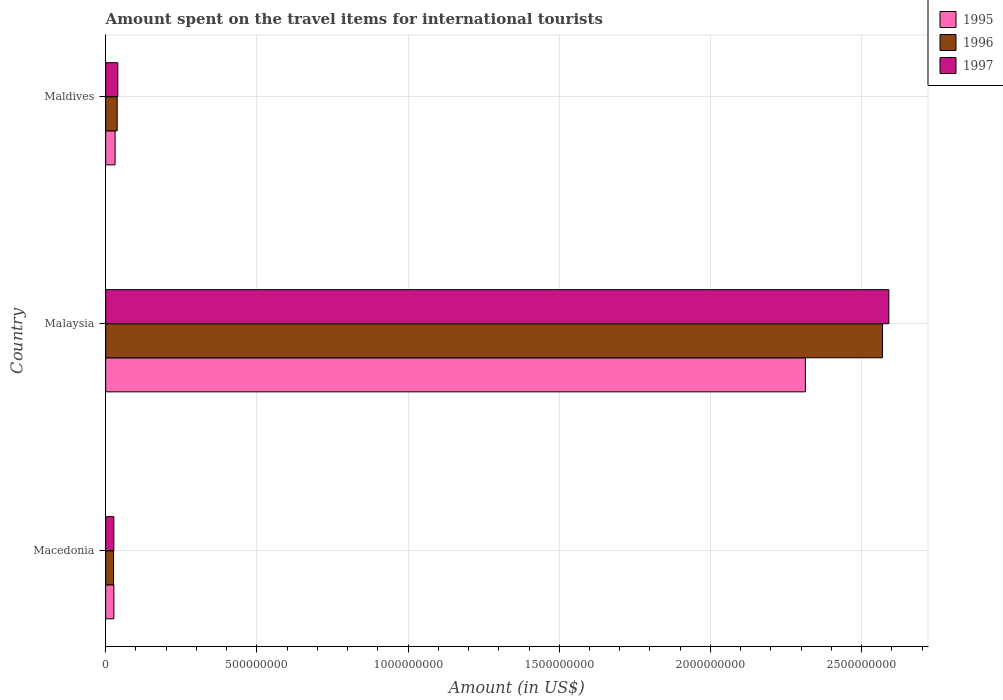Are the number of bars per tick equal to the number of legend labels?
Make the answer very short. Yes. How many bars are there on the 3rd tick from the bottom?
Offer a terse response. 3. What is the label of the 1st group of bars from the top?
Offer a terse response. Maldives. In how many cases, is the number of bars for a given country not equal to the number of legend labels?
Make the answer very short. 0. What is the amount spent on the travel items for international tourists in 1995 in Malaysia?
Offer a very short reply. 2.31e+09. Across all countries, what is the maximum amount spent on the travel items for international tourists in 1995?
Give a very brief answer. 2.31e+09. Across all countries, what is the minimum amount spent on the travel items for international tourists in 1995?
Keep it short and to the point. 2.70e+07. In which country was the amount spent on the travel items for international tourists in 1997 maximum?
Your answer should be compact. Malaysia. In which country was the amount spent on the travel items for international tourists in 1995 minimum?
Keep it short and to the point. Macedonia. What is the total amount spent on the travel items for international tourists in 1997 in the graph?
Your answer should be compact. 2.66e+09. What is the difference between the amount spent on the travel items for international tourists in 1996 in Macedonia and that in Maldives?
Your answer should be compact. -1.20e+07. What is the difference between the amount spent on the travel items for international tourists in 1997 in Malaysia and the amount spent on the travel items for international tourists in 1995 in Maldives?
Ensure brevity in your answer.  2.56e+09. What is the average amount spent on the travel items for international tourists in 1995 per country?
Give a very brief answer. 7.91e+08. In how many countries, is the amount spent on the travel items for international tourists in 1997 greater than 1200000000 US$?
Offer a very short reply. 1. What is the ratio of the amount spent on the travel items for international tourists in 1995 in Macedonia to that in Maldives?
Ensure brevity in your answer.  0.87. Is the amount spent on the travel items for international tourists in 1997 in Macedonia less than that in Malaysia?
Provide a succinct answer. Yes. Is the difference between the amount spent on the travel items for international tourists in 1997 in Macedonia and Maldives greater than the difference between the amount spent on the travel items for international tourists in 1996 in Macedonia and Maldives?
Make the answer very short. No. What is the difference between the highest and the second highest amount spent on the travel items for international tourists in 1995?
Your answer should be compact. 2.28e+09. What is the difference between the highest and the lowest amount spent on the travel items for international tourists in 1997?
Your answer should be very brief. 2.56e+09. In how many countries, is the amount spent on the travel items for international tourists in 1997 greater than the average amount spent on the travel items for international tourists in 1997 taken over all countries?
Ensure brevity in your answer.  1. What does the 2nd bar from the top in Maldives represents?
Make the answer very short. 1996. How many bars are there?
Your response must be concise. 9. Are all the bars in the graph horizontal?
Your answer should be very brief. Yes. How many countries are there in the graph?
Offer a terse response. 3. What is the difference between two consecutive major ticks on the X-axis?
Your answer should be compact. 5.00e+08. Does the graph contain grids?
Give a very brief answer. Yes. Where does the legend appear in the graph?
Your response must be concise. Top right. How many legend labels are there?
Give a very brief answer. 3. How are the legend labels stacked?
Ensure brevity in your answer.  Vertical. What is the title of the graph?
Give a very brief answer. Amount spent on the travel items for international tourists. Does "2003" appear as one of the legend labels in the graph?
Your answer should be compact. No. What is the Amount (in US$) of 1995 in Macedonia?
Your answer should be compact. 2.70e+07. What is the Amount (in US$) of 1996 in Macedonia?
Your response must be concise. 2.60e+07. What is the Amount (in US$) of 1997 in Macedonia?
Offer a terse response. 2.70e+07. What is the Amount (in US$) of 1995 in Malaysia?
Offer a very short reply. 2.31e+09. What is the Amount (in US$) in 1996 in Malaysia?
Offer a very short reply. 2.57e+09. What is the Amount (in US$) in 1997 in Malaysia?
Offer a terse response. 2.59e+09. What is the Amount (in US$) in 1995 in Maldives?
Make the answer very short. 3.10e+07. What is the Amount (in US$) in 1996 in Maldives?
Your answer should be very brief. 3.80e+07. What is the Amount (in US$) of 1997 in Maldives?
Provide a succinct answer. 4.00e+07. Across all countries, what is the maximum Amount (in US$) in 1995?
Provide a short and direct response. 2.31e+09. Across all countries, what is the maximum Amount (in US$) in 1996?
Make the answer very short. 2.57e+09. Across all countries, what is the maximum Amount (in US$) of 1997?
Your response must be concise. 2.59e+09. Across all countries, what is the minimum Amount (in US$) in 1995?
Your answer should be compact. 2.70e+07. Across all countries, what is the minimum Amount (in US$) of 1996?
Your answer should be very brief. 2.60e+07. Across all countries, what is the minimum Amount (in US$) in 1997?
Provide a short and direct response. 2.70e+07. What is the total Amount (in US$) in 1995 in the graph?
Provide a short and direct response. 2.37e+09. What is the total Amount (in US$) of 1996 in the graph?
Your answer should be compact. 2.63e+09. What is the total Amount (in US$) of 1997 in the graph?
Ensure brevity in your answer.  2.66e+09. What is the difference between the Amount (in US$) of 1995 in Macedonia and that in Malaysia?
Provide a succinct answer. -2.29e+09. What is the difference between the Amount (in US$) in 1996 in Macedonia and that in Malaysia?
Keep it short and to the point. -2.54e+09. What is the difference between the Amount (in US$) of 1997 in Macedonia and that in Malaysia?
Your answer should be compact. -2.56e+09. What is the difference between the Amount (in US$) in 1996 in Macedonia and that in Maldives?
Your answer should be very brief. -1.20e+07. What is the difference between the Amount (in US$) of 1997 in Macedonia and that in Maldives?
Make the answer very short. -1.30e+07. What is the difference between the Amount (in US$) of 1995 in Malaysia and that in Maldives?
Your answer should be compact. 2.28e+09. What is the difference between the Amount (in US$) in 1996 in Malaysia and that in Maldives?
Ensure brevity in your answer.  2.53e+09. What is the difference between the Amount (in US$) of 1997 in Malaysia and that in Maldives?
Offer a terse response. 2.55e+09. What is the difference between the Amount (in US$) in 1995 in Macedonia and the Amount (in US$) in 1996 in Malaysia?
Keep it short and to the point. -2.54e+09. What is the difference between the Amount (in US$) of 1995 in Macedonia and the Amount (in US$) of 1997 in Malaysia?
Give a very brief answer. -2.56e+09. What is the difference between the Amount (in US$) of 1996 in Macedonia and the Amount (in US$) of 1997 in Malaysia?
Offer a terse response. -2.56e+09. What is the difference between the Amount (in US$) of 1995 in Macedonia and the Amount (in US$) of 1996 in Maldives?
Offer a very short reply. -1.10e+07. What is the difference between the Amount (in US$) of 1995 in Macedonia and the Amount (in US$) of 1997 in Maldives?
Your answer should be compact. -1.30e+07. What is the difference between the Amount (in US$) of 1996 in Macedonia and the Amount (in US$) of 1997 in Maldives?
Make the answer very short. -1.40e+07. What is the difference between the Amount (in US$) in 1995 in Malaysia and the Amount (in US$) in 1996 in Maldives?
Your response must be concise. 2.28e+09. What is the difference between the Amount (in US$) in 1995 in Malaysia and the Amount (in US$) in 1997 in Maldives?
Offer a terse response. 2.27e+09. What is the difference between the Amount (in US$) in 1996 in Malaysia and the Amount (in US$) in 1997 in Maldives?
Provide a succinct answer. 2.53e+09. What is the average Amount (in US$) in 1995 per country?
Ensure brevity in your answer.  7.91e+08. What is the average Amount (in US$) of 1996 per country?
Your answer should be very brief. 8.78e+08. What is the average Amount (in US$) in 1997 per country?
Your response must be concise. 8.86e+08. What is the difference between the Amount (in US$) of 1995 and Amount (in US$) of 1997 in Macedonia?
Offer a very short reply. 0. What is the difference between the Amount (in US$) of 1996 and Amount (in US$) of 1997 in Macedonia?
Ensure brevity in your answer.  -1.00e+06. What is the difference between the Amount (in US$) in 1995 and Amount (in US$) in 1996 in Malaysia?
Provide a short and direct response. -2.55e+08. What is the difference between the Amount (in US$) in 1995 and Amount (in US$) in 1997 in Malaysia?
Offer a very short reply. -2.76e+08. What is the difference between the Amount (in US$) of 1996 and Amount (in US$) of 1997 in Malaysia?
Keep it short and to the point. -2.10e+07. What is the difference between the Amount (in US$) in 1995 and Amount (in US$) in 1996 in Maldives?
Ensure brevity in your answer.  -7.00e+06. What is the difference between the Amount (in US$) of 1995 and Amount (in US$) of 1997 in Maldives?
Keep it short and to the point. -9.00e+06. What is the difference between the Amount (in US$) of 1996 and Amount (in US$) of 1997 in Maldives?
Provide a short and direct response. -2.00e+06. What is the ratio of the Amount (in US$) in 1995 in Macedonia to that in Malaysia?
Provide a succinct answer. 0.01. What is the ratio of the Amount (in US$) of 1996 in Macedonia to that in Malaysia?
Offer a terse response. 0.01. What is the ratio of the Amount (in US$) in 1997 in Macedonia to that in Malaysia?
Provide a short and direct response. 0.01. What is the ratio of the Amount (in US$) of 1995 in Macedonia to that in Maldives?
Offer a very short reply. 0.87. What is the ratio of the Amount (in US$) in 1996 in Macedonia to that in Maldives?
Keep it short and to the point. 0.68. What is the ratio of the Amount (in US$) of 1997 in Macedonia to that in Maldives?
Your answer should be very brief. 0.68. What is the ratio of the Amount (in US$) of 1995 in Malaysia to that in Maldives?
Offer a very short reply. 74.65. What is the ratio of the Amount (in US$) in 1996 in Malaysia to that in Maldives?
Give a very brief answer. 67.61. What is the ratio of the Amount (in US$) of 1997 in Malaysia to that in Maldives?
Your answer should be very brief. 64.75. What is the difference between the highest and the second highest Amount (in US$) of 1995?
Provide a succinct answer. 2.28e+09. What is the difference between the highest and the second highest Amount (in US$) of 1996?
Provide a short and direct response. 2.53e+09. What is the difference between the highest and the second highest Amount (in US$) of 1997?
Give a very brief answer. 2.55e+09. What is the difference between the highest and the lowest Amount (in US$) in 1995?
Your answer should be very brief. 2.29e+09. What is the difference between the highest and the lowest Amount (in US$) of 1996?
Provide a succinct answer. 2.54e+09. What is the difference between the highest and the lowest Amount (in US$) of 1997?
Offer a very short reply. 2.56e+09. 